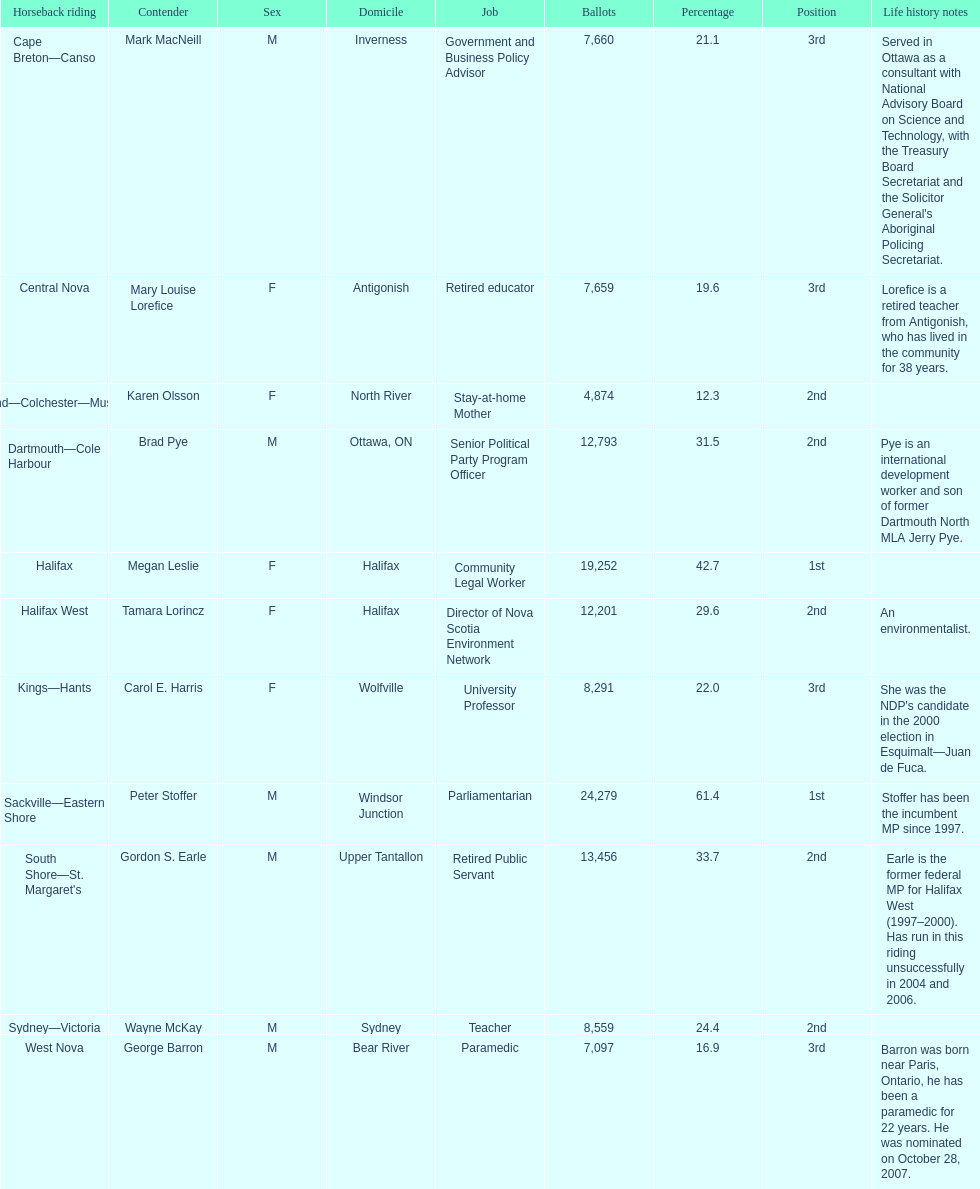Who received the least amount of votes? Karen Olsson. 